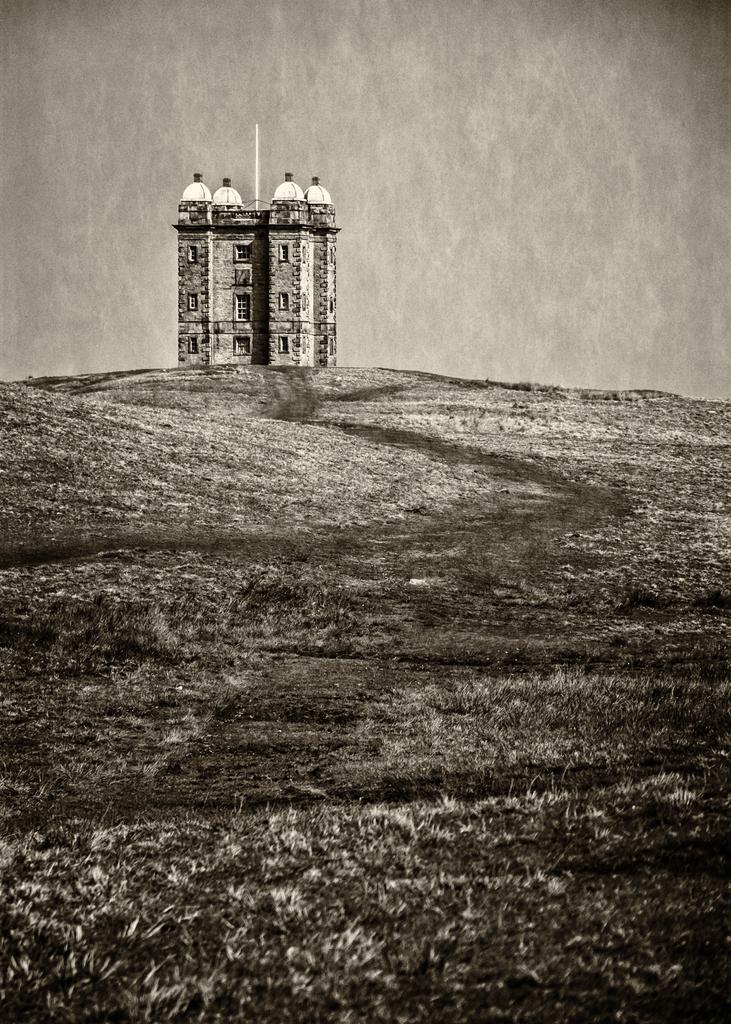Could you give a brief overview of what you see in this image? It looks like a black and white picture, we can see a building on the path. 